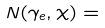Convert formula to latex. <formula><loc_0><loc_0><loc_500><loc_500>N ( \gamma _ { e } , \chi ) =</formula> 